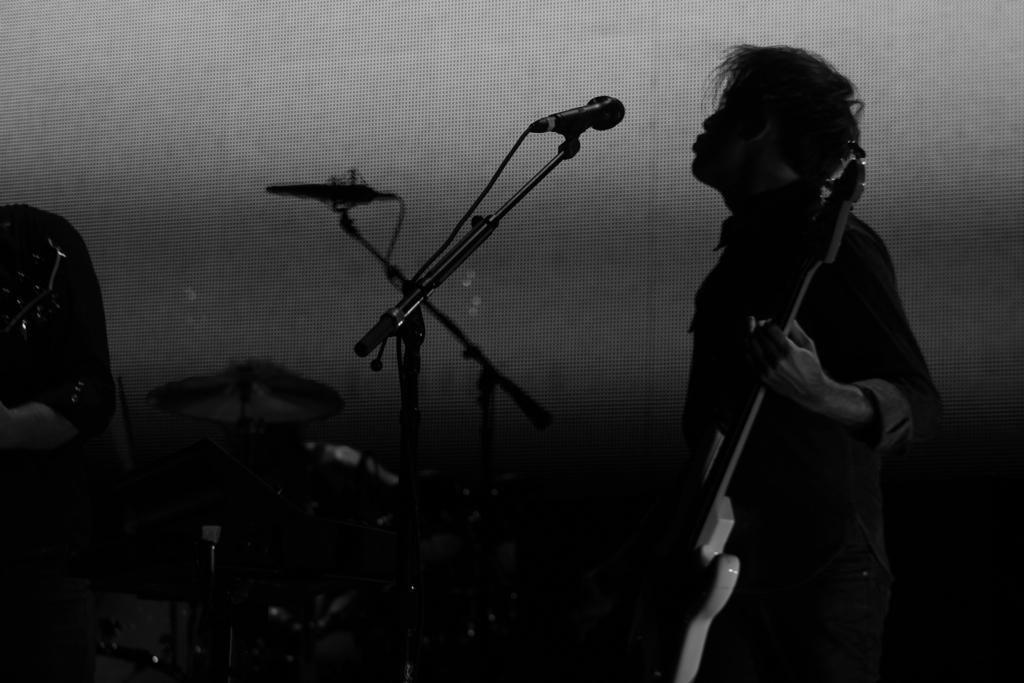What is the person in the image holding? The person is holding a guitar in the image. What object is present for amplifying sound? There is a microphone (mike) in the image. Where are the musical instruments located in the image? The musical instruments are on the left side of the image. What can be seen in the background of the image? There is a wall in the background of the image. What type of tail can be seen on the person holding the guitar in the image? There is no tail present on the person holding the guitar in the image. 